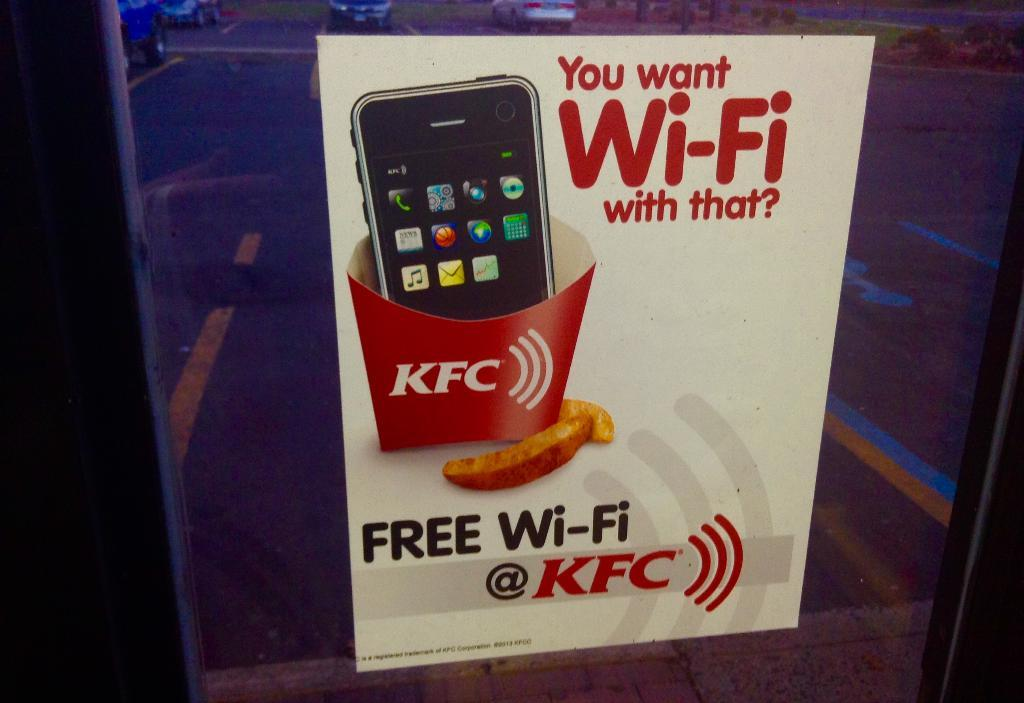<image>
Present a compact description of the photo's key features. Poster showing a cell phone sitting in a KFC food box asking "You want Wi-Fi with that?". 